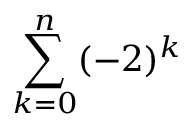Convert formula to latex. <formula><loc_0><loc_0><loc_500><loc_500>\sum _ { k = 0 } ^ { n } ( - 2 ) ^ { k }</formula> 